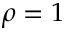Convert formula to latex. <formula><loc_0><loc_0><loc_500><loc_500>\rho = 1</formula> 